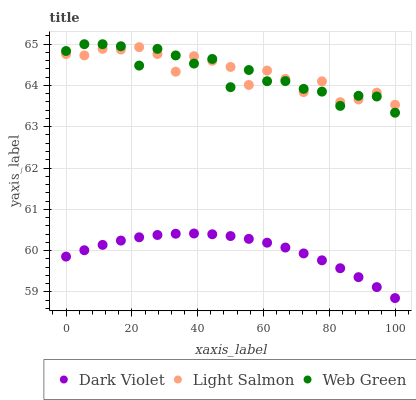Does Dark Violet have the minimum area under the curve?
Answer yes or no. Yes. Does Light Salmon have the maximum area under the curve?
Answer yes or no. Yes. Does Web Green have the minimum area under the curve?
Answer yes or no. No. Does Web Green have the maximum area under the curve?
Answer yes or no. No. Is Dark Violet the smoothest?
Answer yes or no. Yes. Is Web Green the roughest?
Answer yes or no. Yes. Is Web Green the smoothest?
Answer yes or no. No. Is Dark Violet the roughest?
Answer yes or no. No. Does Dark Violet have the lowest value?
Answer yes or no. Yes. Does Web Green have the lowest value?
Answer yes or no. No. Does Web Green have the highest value?
Answer yes or no. Yes. Does Dark Violet have the highest value?
Answer yes or no. No. Is Dark Violet less than Web Green?
Answer yes or no. Yes. Is Light Salmon greater than Dark Violet?
Answer yes or no. Yes. Does Light Salmon intersect Web Green?
Answer yes or no. Yes. Is Light Salmon less than Web Green?
Answer yes or no. No. Is Light Salmon greater than Web Green?
Answer yes or no. No. Does Dark Violet intersect Web Green?
Answer yes or no. No. 